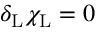<formula> <loc_0><loc_0><loc_500><loc_500>\delta _ { L } \chi _ { L } = 0</formula> 